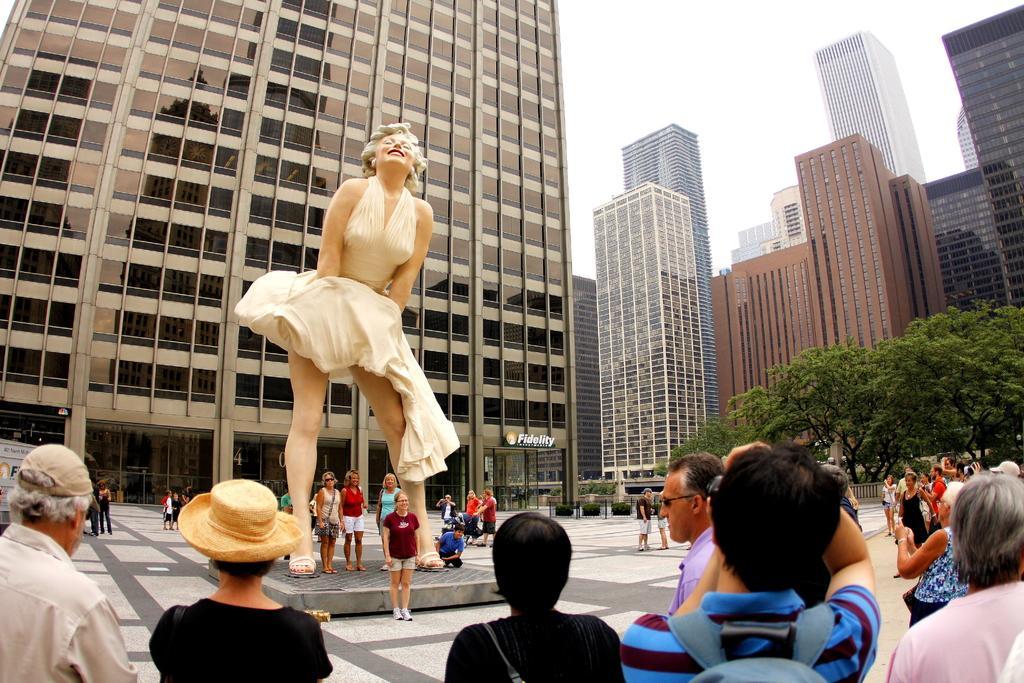Please provide a concise description of this image. In this picture we can see some people are standing, there is a statue in the middle, on the right side we can see trees, there are some trees in the background, we can see the sky at the top of the picture. 